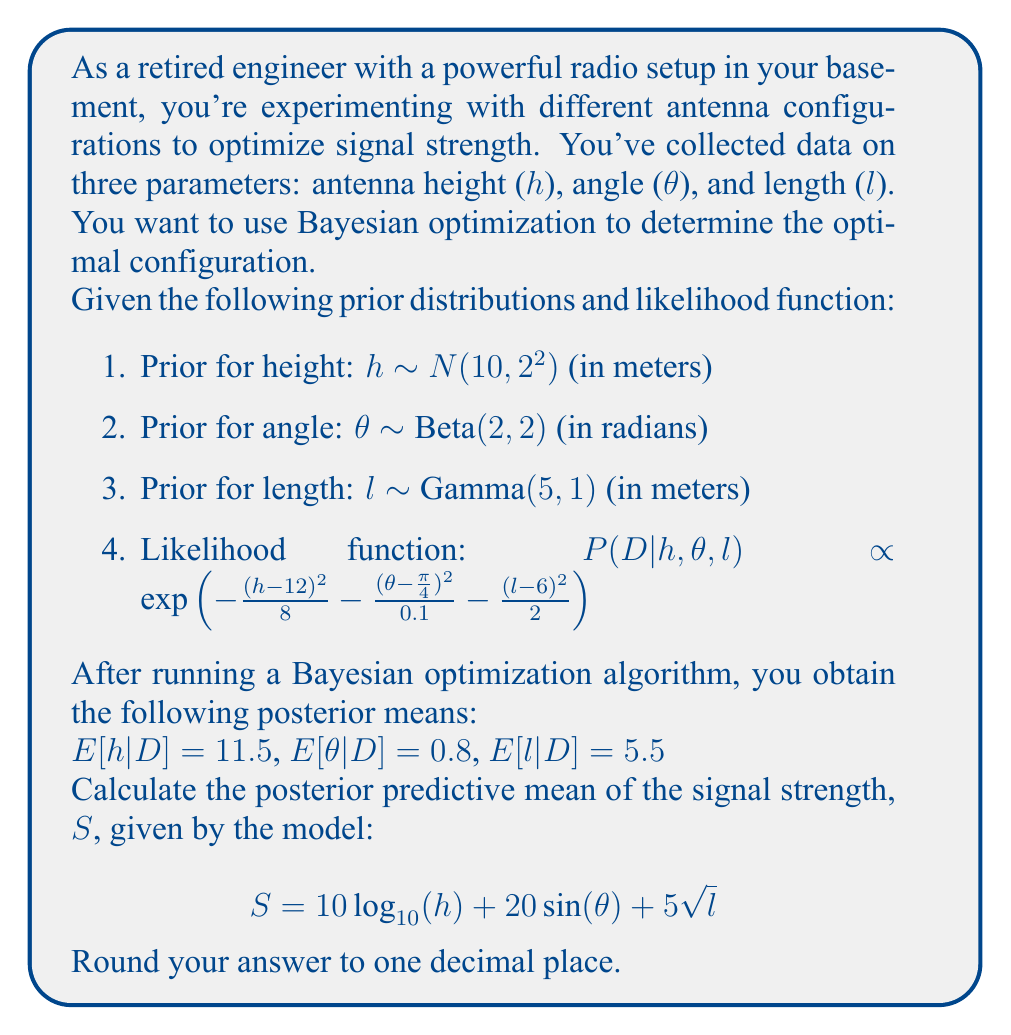What is the answer to this math problem? To calculate the posterior predictive mean of the signal strength, we need to use the posterior means of h, θ, and l in the given model. Let's go through this step-by-step:

1. We have the posterior means:
   $E[h|D] = 11.5$
   $E[\theta|D] = 0.8$
   $E[l|D] = 5.5$

2. The model for signal strength is:
   $$S = 10 \log_{10}(h) + 20 \sin(\theta) + 5\sqrt{l}$$

3. We'll substitute the posterior means into this equation:

   $S = 10 \log_{10}(11.5) + 20 \sin(0.8) + 5\sqrt{5.5}$

4. Let's calculate each term:
   
   a) $10 \log_{10}(11.5) = 10.60698$
   
   b) $20 \sin(0.8) = 14.26566$
   
   c) $5\sqrt{5.5} = 11.70470$

5. Now, we sum these terms:

   $S = 10.60698 + 14.26566 + 11.70470 = 36.57734$

6. Rounding to one decimal place:

   $S \approx 36.6$

Therefore, the posterior predictive mean of the signal strength is approximately 36.6.
Answer: 36.6 